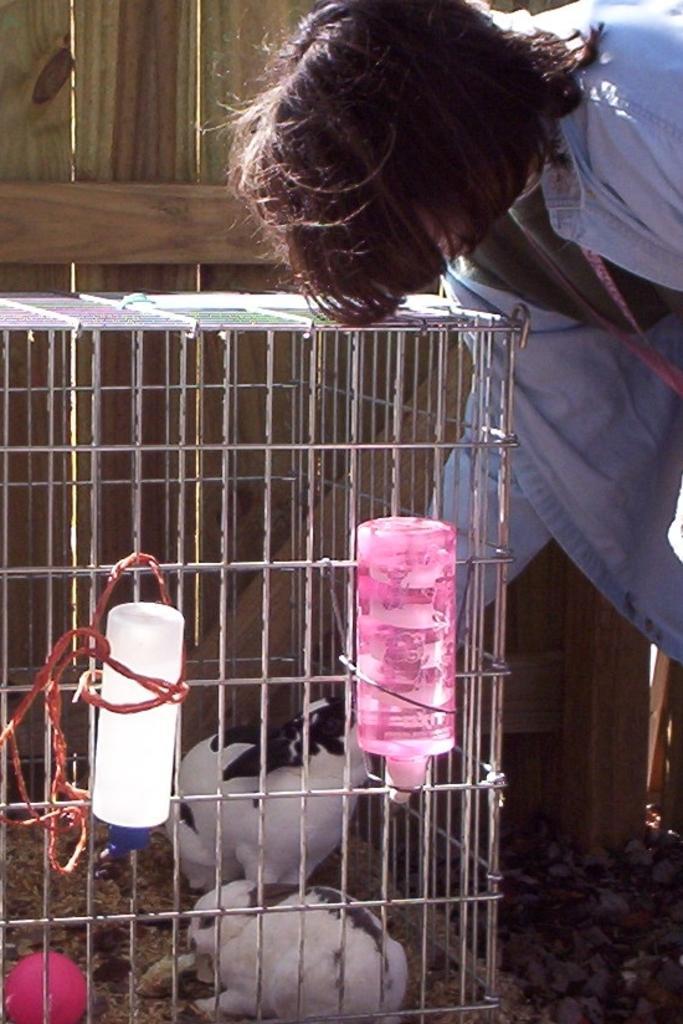Could you give a brief overview of what you see in this image? In this picture I can see a kennel in front and in the kennel, I can see 2 rabbits and a pink color thing and I can see 2 bottles tied to the kennel. On the right side of this picture I can see a person. In the background I can see the wooden thing. 